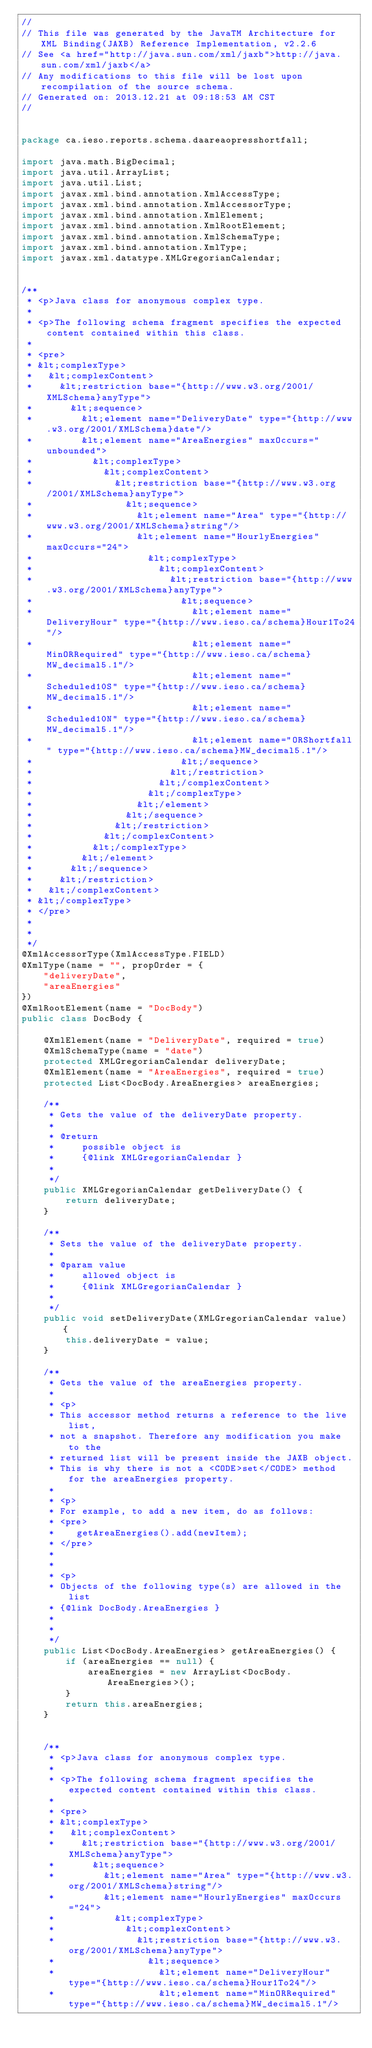Convert code to text. <code><loc_0><loc_0><loc_500><loc_500><_Java_>//
// This file was generated by the JavaTM Architecture for XML Binding(JAXB) Reference Implementation, v2.2.6 
// See <a href="http://java.sun.com/xml/jaxb">http://java.sun.com/xml/jaxb</a> 
// Any modifications to this file will be lost upon recompilation of the source schema. 
// Generated on: 2013.12.21 at 09:18:53 AM CST 
//


package ca.ieso.reports.schema.daareaopresshortfall;

import java.math.BigDecimal;
import java.util.ArrayList;
import java.util.List;
import javax.xml.bind.annotation.XmlAccessType;
import javax.xml.bind.annotation.XmlAccessorType;
import javax.xml.bind.annotation.XmlElement;
import javax.xml.bind.annotation.XmlRootElement;
import javax.xml.bind.annotation.XmlSchemaType;
import javax.xml.bind.annotation.XmlType;
import javax.xml.datatype.XMLGregorianCalendar;


/**
 * <p>Java class for anonymous complex type.
 * 
 * <p>The following schema fragment specifies the expected content contained within this class.
 * 
 * <pre>
 * &lt;complexType>
 *   &lt;complexContent>
 *     &lt;restriction base="{http://www.w3.org/2001/XMLSchema}anyType">
 *       &lt;sequence>
 *         &lt;element name="DeliveryDate" type="{http://www.w3.org/2001/XMLSchema}date"/>
 *         &lt;element name="AreaEnergies" maxOccurs="unbounded">
 *           &lt;complexType>
 *             &lt;complexContent>
 *               &lt;restriction base="{http://www.w3.org/2001/XMLSchema}anyType">
 *                 &lt;sequence>
 *                   &lt;element name="Area" type="{http://www.w3.org/2001/XMLSchema}string"/>
 *                   &lt;element name="HourlyEnergies" maxOccurs="24">
 *                     &lt;complexType>
 *                       &lt;complexContent>
 *                         &lt;restriction base="{http://www.w3.org/2001/XMLSchema}anyType">
 *                           &lt;sequence>
 *                             &lt;element name="DeliveryHour" type="{http://www.ieso.ca/schema}Hour1To24"/>
 *                             &lt;element name="MinORRequired" type="{http://www.ieso.ca/schema}MW_decimal5.1"/>
 *                             &lt;element name="Scheduled10S" type="{http://www.ieso.ca/schema}MW_decimal5.1"/>
 *                             &lt;element name="Scheduled10N" type="{http://www.ieso.ca/schema}MW_decimal5.1"/>
 *                             &lt;element name="ORShortfall" type="{http://www.ieso.ca/schema}MW_decimal5.1"/>
 *                           &lt;/sequence>
 *                         &lt;/restriction>
 *                       &lt;/complexContent>
 *                     &lt;/complexType>
 *                   &lt;/element>
 *                 &lt;/sequence>
 *               &lt;/restriction>
 *             &lt;/complexContent>
 *           &lt;/complexType>
 *         &lt;/element>
 *       &lt;/sequence>
 *     &lt;/restriction>
 *   &lt;/complexContent>
 * &lt;/complexType>
 * </pre>
 * 
 * 
 */
@XmlAccessorType(XmlAccessType.FIELD)
@XmlType(name = "", propOrder = {
    "deliveryDate",
    "areaEnergies"
})
@XmlRootElement(name = "DocBody")
public class DocBody {

    @XmlElement(name = "DeliveryDate", required = true)
    @XmlSchemaType(name = "date")
    protected XMLGregorianCalendar deliveryDate;
    @XmlElement(name = "AreaEnergies", required = true)
    protected List<DocBody.AreaEnergies> areaEnergies;

    /**
     * Gets the value of the deliveryDate property.
     * 
     * @return
     *     possible object is
     *     {@link XMLGregorianCalendar }
     *     
     */
    public XMLGregorianCalendar getDeliveryDate() {
        return deliveryDate;
    }

    /**
     * Sets the value of the deliveryDate property.
     * 
     * @param value
     *     allowed object is
     *     {@link XMLGregorianCalendar }
     *     
     */
    public void setDeliveryDate(XMLGregorianCalendar value) {
        this.deliveryDate = value;
    }

    /**
     * Gets the value of the areaEnergies property.
     * 
     * <p>
     * This accessor method returns a reference to the live list,
     * not a snapshot. Therefore any modification you make to the
     * returned list will be present inside the JAXB object.
     * This is why there is not a <CODE>set</CODE> method for the areaEnergies property.
     * 
     * <p>
     * For example, to add a new item, do as follows:
     * <pre>
     *    getAreaEnergies().add(newItem);
     * </pre>
     * 
     * 
     * <p>
     * Objects of the following type(s) are allowed in the list
     * {@link DocBody.AreaEnergies }
     * 
     * 
     */
    public List<DocBody.AreaEnergies> getAreaEnergies() {
        if (areaEnergies == null) {
            areaEnergies = new ArrayList<DocBody.AreaEnergies>();
        }
        return this.areaEnergies;
    }


    /**
     * <p>Java class for anonymous complex type.
     * 
     * <p>The following schema fragment specifies the expected content contained within this class.
     * 
     * <pre>
     * &lt;complexType>
     *   &lt;complexContent>
     *     &lt;restriction base="{http://www.w3.org/2001/XMLSchema}anyType">
     *       &lt;sequence>
     *         &lt;element name="Area" type="{http://www.w3.org/2001/XMLSchema}string"/>
     *         &lt;element name="HourlyEnergies" maxOccurs="24">
     *           &lt;complexType>
     *             &lt;complexContent>
     *               &lt;restriction base="{http://www.w3.org/2001/XMLSchema}anyType">
     *                 &lt;sequence>
     *                   &lt;element name="DeliveryHour" type="{http://www.ieso.ca/schema}Hour1To24"/>
     *                   &lt;element name="MinORRequired" type="{http://www.ieso.ca/schema}MW_decimal5.1"/></code> 